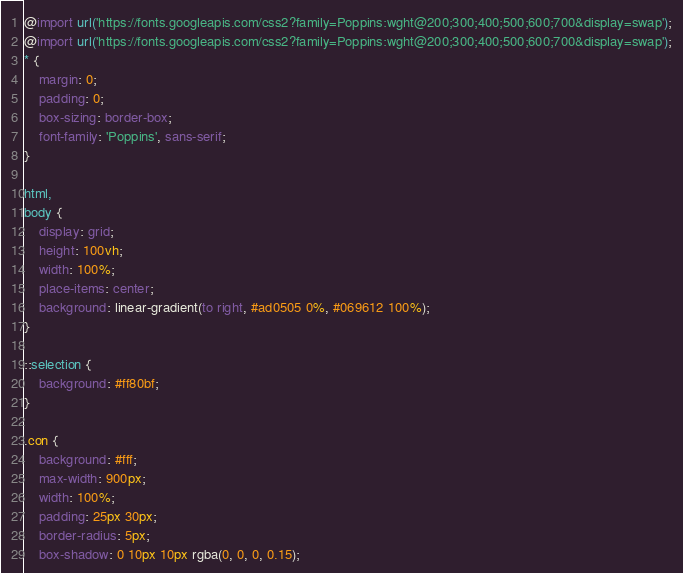Convert code to text. <code><loc_0><loc_0><loc_500><loc_500><_CSS_>@import url('https://fonts.googleapis.com/css2?family=Poppins:wght@200;300;400;500;600;700&display=swap');
@import url('https://fonts.googleapis.com/css2?family=Poppins:wght@200;300;400;500;600;700&display=swap');
* {
    margin: 0;
    padding: 0;
    box-sizing: border-box;
    font-family: 'Poppins', sans-serif;
}

html,
body {
    display: grid;
    height: 100vh;
    width: 100%;
    place-items: center;
    background: linear-gradient(to right, #ad0505 0%, #069612 100%);
}

::selection {
    background: #ff80bf;
}

.con {
    background: #fff;
    max-width: 900px;
    width: 100%;
    padding: 25px 30px;
    border-radius: 5px;
    box-shadow: 0 10px 10px rgba(0, 0, 0, 0.15);</code> 